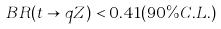Convert formula to latex. <formula><loc_0><loc_0><loc_500><loc_500>B R ( t \rightarrow q Z ) < 0 . 4 1 ( 9 0 \% C . L . )</formula> 